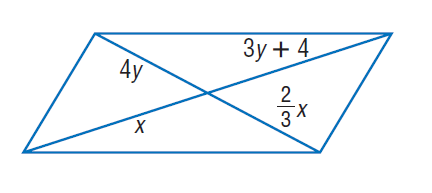Answer the mathemtical geometry problem and directly provide the correct option letter.
Question: Find y and so that the quadrilateral is a parallelogram.
Choices: A: \frac { 2 } { 3 } B: \frac { 4 } { 3 } C: \frac { 16 } { 3 } D: 7 B 